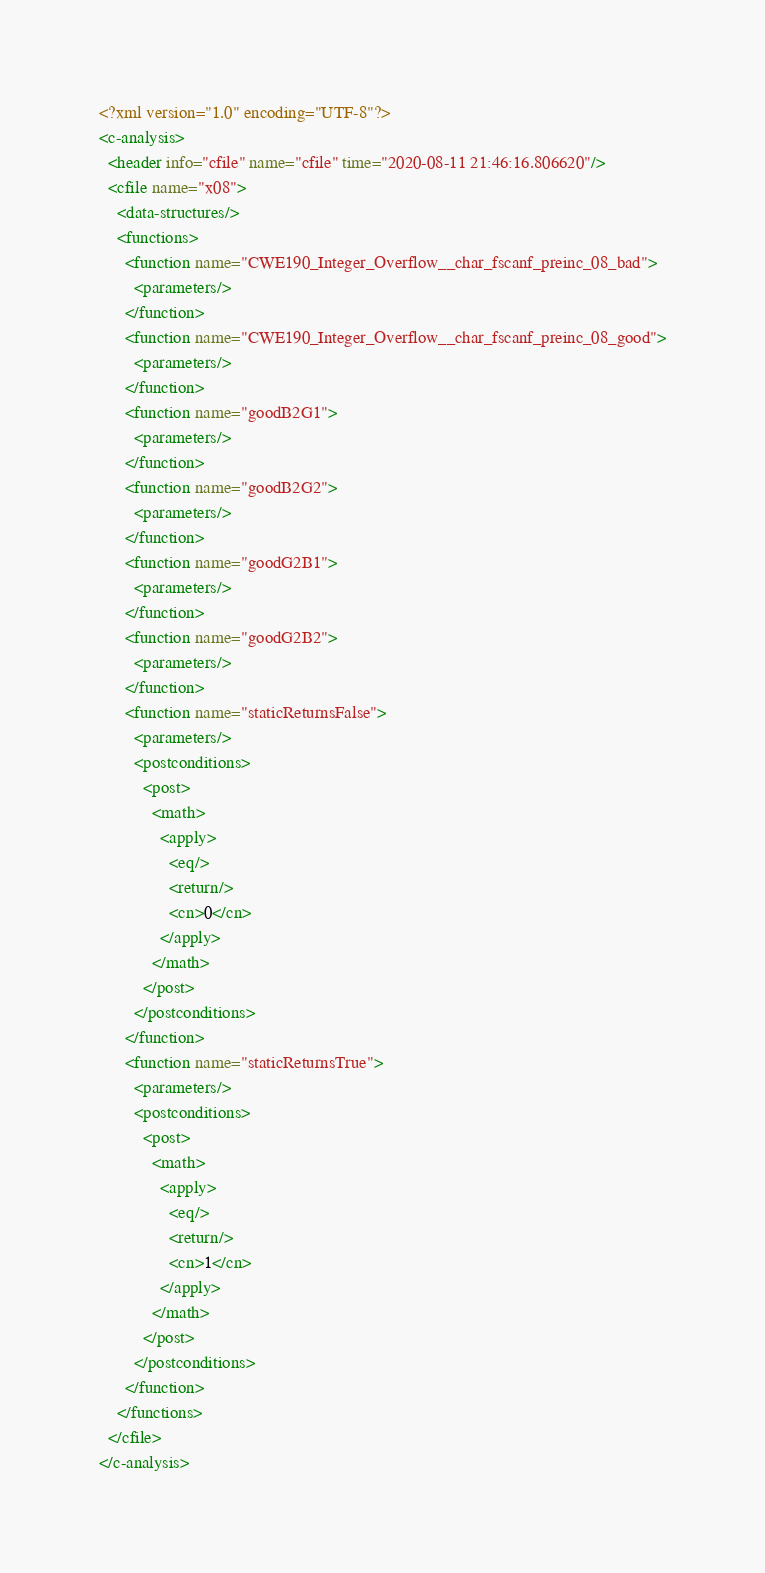<code> <loc_0><loc_0><loc_500><loc_500><_XML_><?xml version="1.0" encoding="UTF-8"?>
<c-analysis>
  <header info="cfile" name="cfile" time="2020-08-11 21:46:16.806620"/>
  <cfile name="x08">
    <data-structures/>
    <functions>
      <function name="CWE190_Integer_Overflow__char_fscanf_preinc_08_bad">
        <parameters/>
      </function>
      <function name="CWE190_Integer_Overflow__char_fscanf_preinc_08_good">
        <parameters/>
      </function>
      <function name="goodB2G1">
        <parameters/>
      </function>
      <function name="goodB2G2">
        <parameters/>
      </function>
      <function name="goodG2B1">
        <parameters/>
      </function>
      <function name="goodG2B2">
        <parameters/>
      </function>
      <function name="staticReturnsFalse">
        <parameters/>
        <postconditions>
          <post>
            <math>
              <apply>
                <eq/>
                <return/>
                <cn>0</cn>
              </apply>
            </math>
          </post>
        </postconditions>
      </function>
      <function name="staticReturnsTrue">
        <parameters/>
        <postconditions>
          <post>
            <math>
              <apply>
                <eq/>
                <return/>
                <cn>1</cn>
              </apply>
            </math>
          </post>
        </postconditions>
      </function>
    </functions>
  </cfile>
</c-analysis>
</code> 